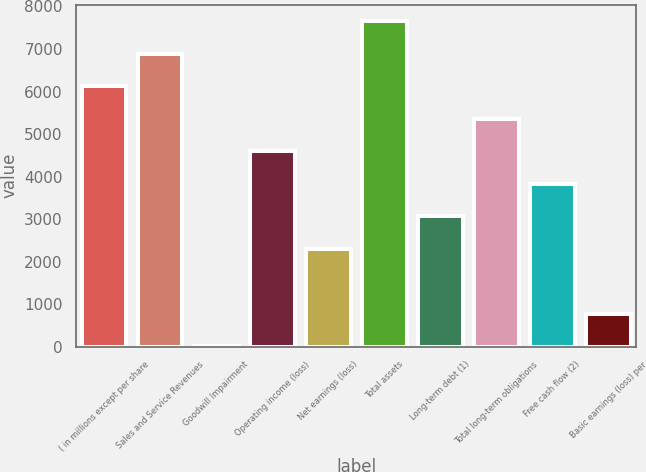Convert chart. <chart><loc_0><loc_0><loc_500><loc_500><bar_chart><fcel>( in millions except per share<fcel>Sales and Service Revenues<fcel>Goodwill Impairment<fcel>Operating income (loss)<fcel>Net earnings (loss)<fcel>Total assets<fcel>Long-term debt (1)<fcel>Total long-term obligations<fcel>Free cash flow (2)<fcel>Basic earnings (loss) per<nl><fcel>6127.25<fcel>6892.63<fcel>4.21<fcel>4596.49<fcel>2300.35<fcel>7658.01<fcel>3065.73<fcel>5361.87<fcel>3831.11<fcel>769.59<nl></chart> 